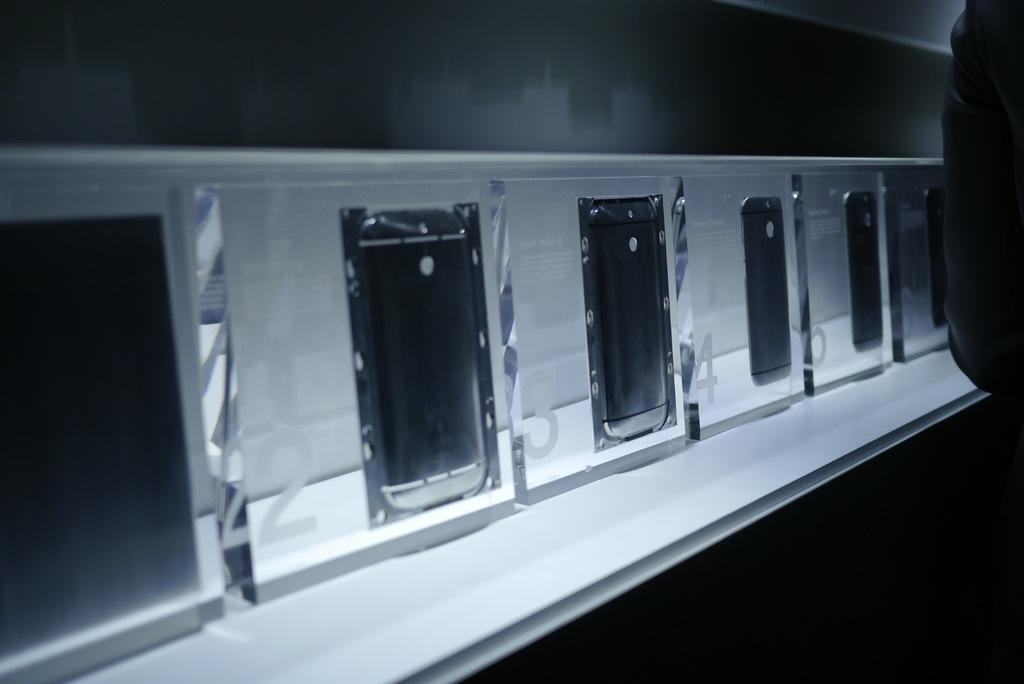Provide a one-sentence caption for the provided image. The windows are numbered 22, 23, 24, 25, and so on. 